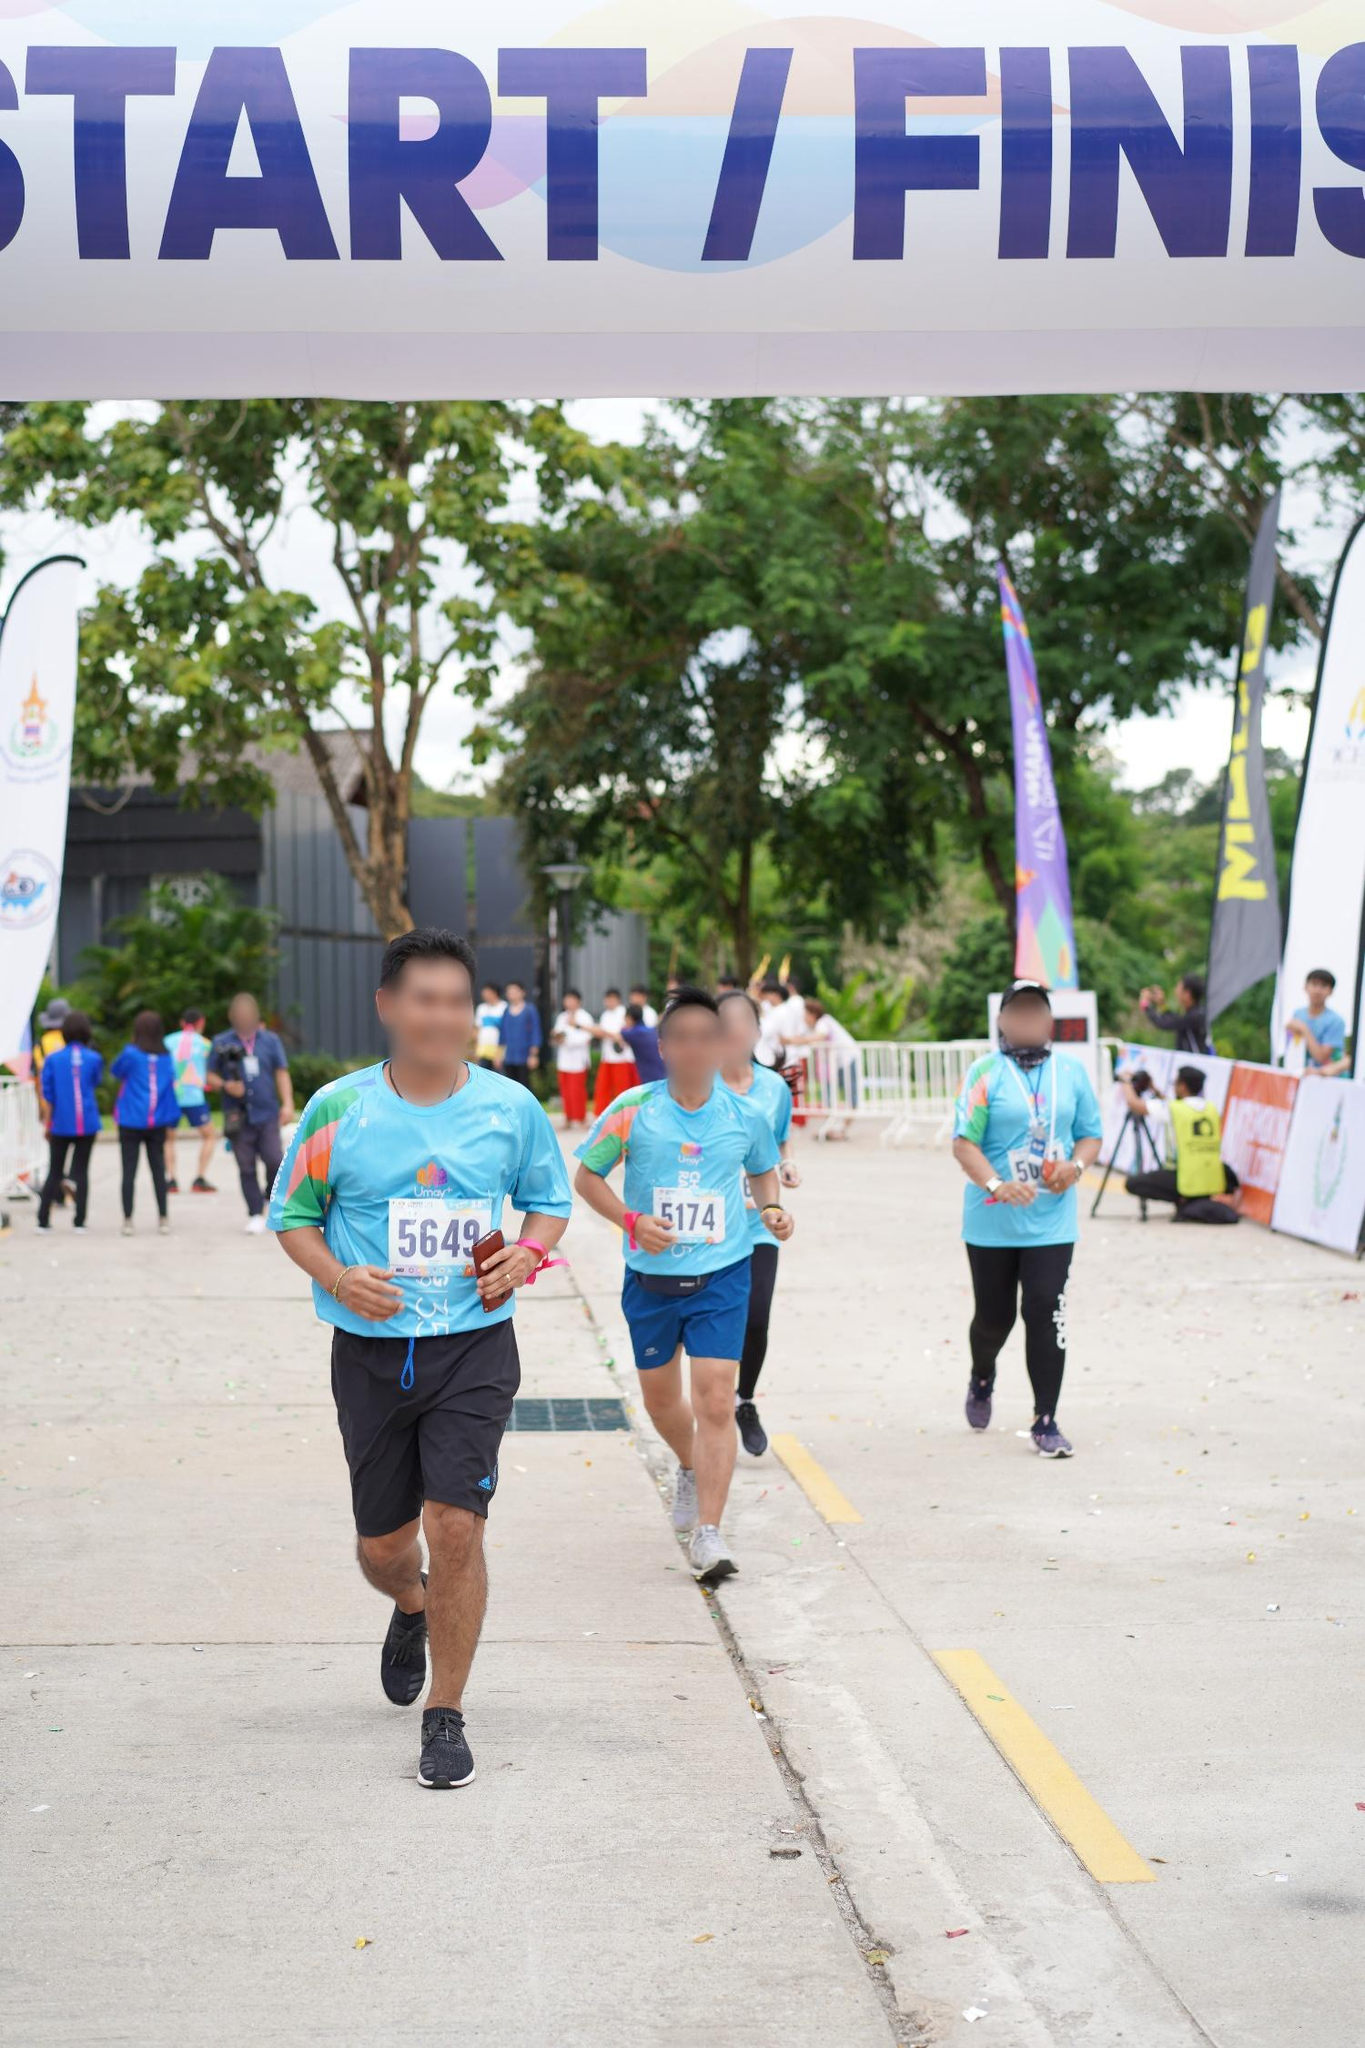Describe the background activities in the scene. In the background, various activities can be seen that add to the vibrancy of the race event. Volunteers and other participants are mingling, possibly preparing for their turn or cheering on the runners. The presence of banners and flags indicates sponsor involvement and event organization. There seems to be a mix of spectators and participants gathered, enhancing the communal feel of the event. The greenery and natural elements create a picturesque setting, amplifying the scenic beauty of the event. What might be going through the minds of the organizers at this moment? The organizers are likely focused on ensuring the smooth running of the event. They may be feeling a mix of pride and anticipation, closely watching the progress of the runners and overseeing logistics. Their main concerns might include the safety of the participants, the efficiency of the race processes, and making sure that everything goes according to plan. They might also be feeling satisfaction seeing the successful turnout and engagement from the community. 